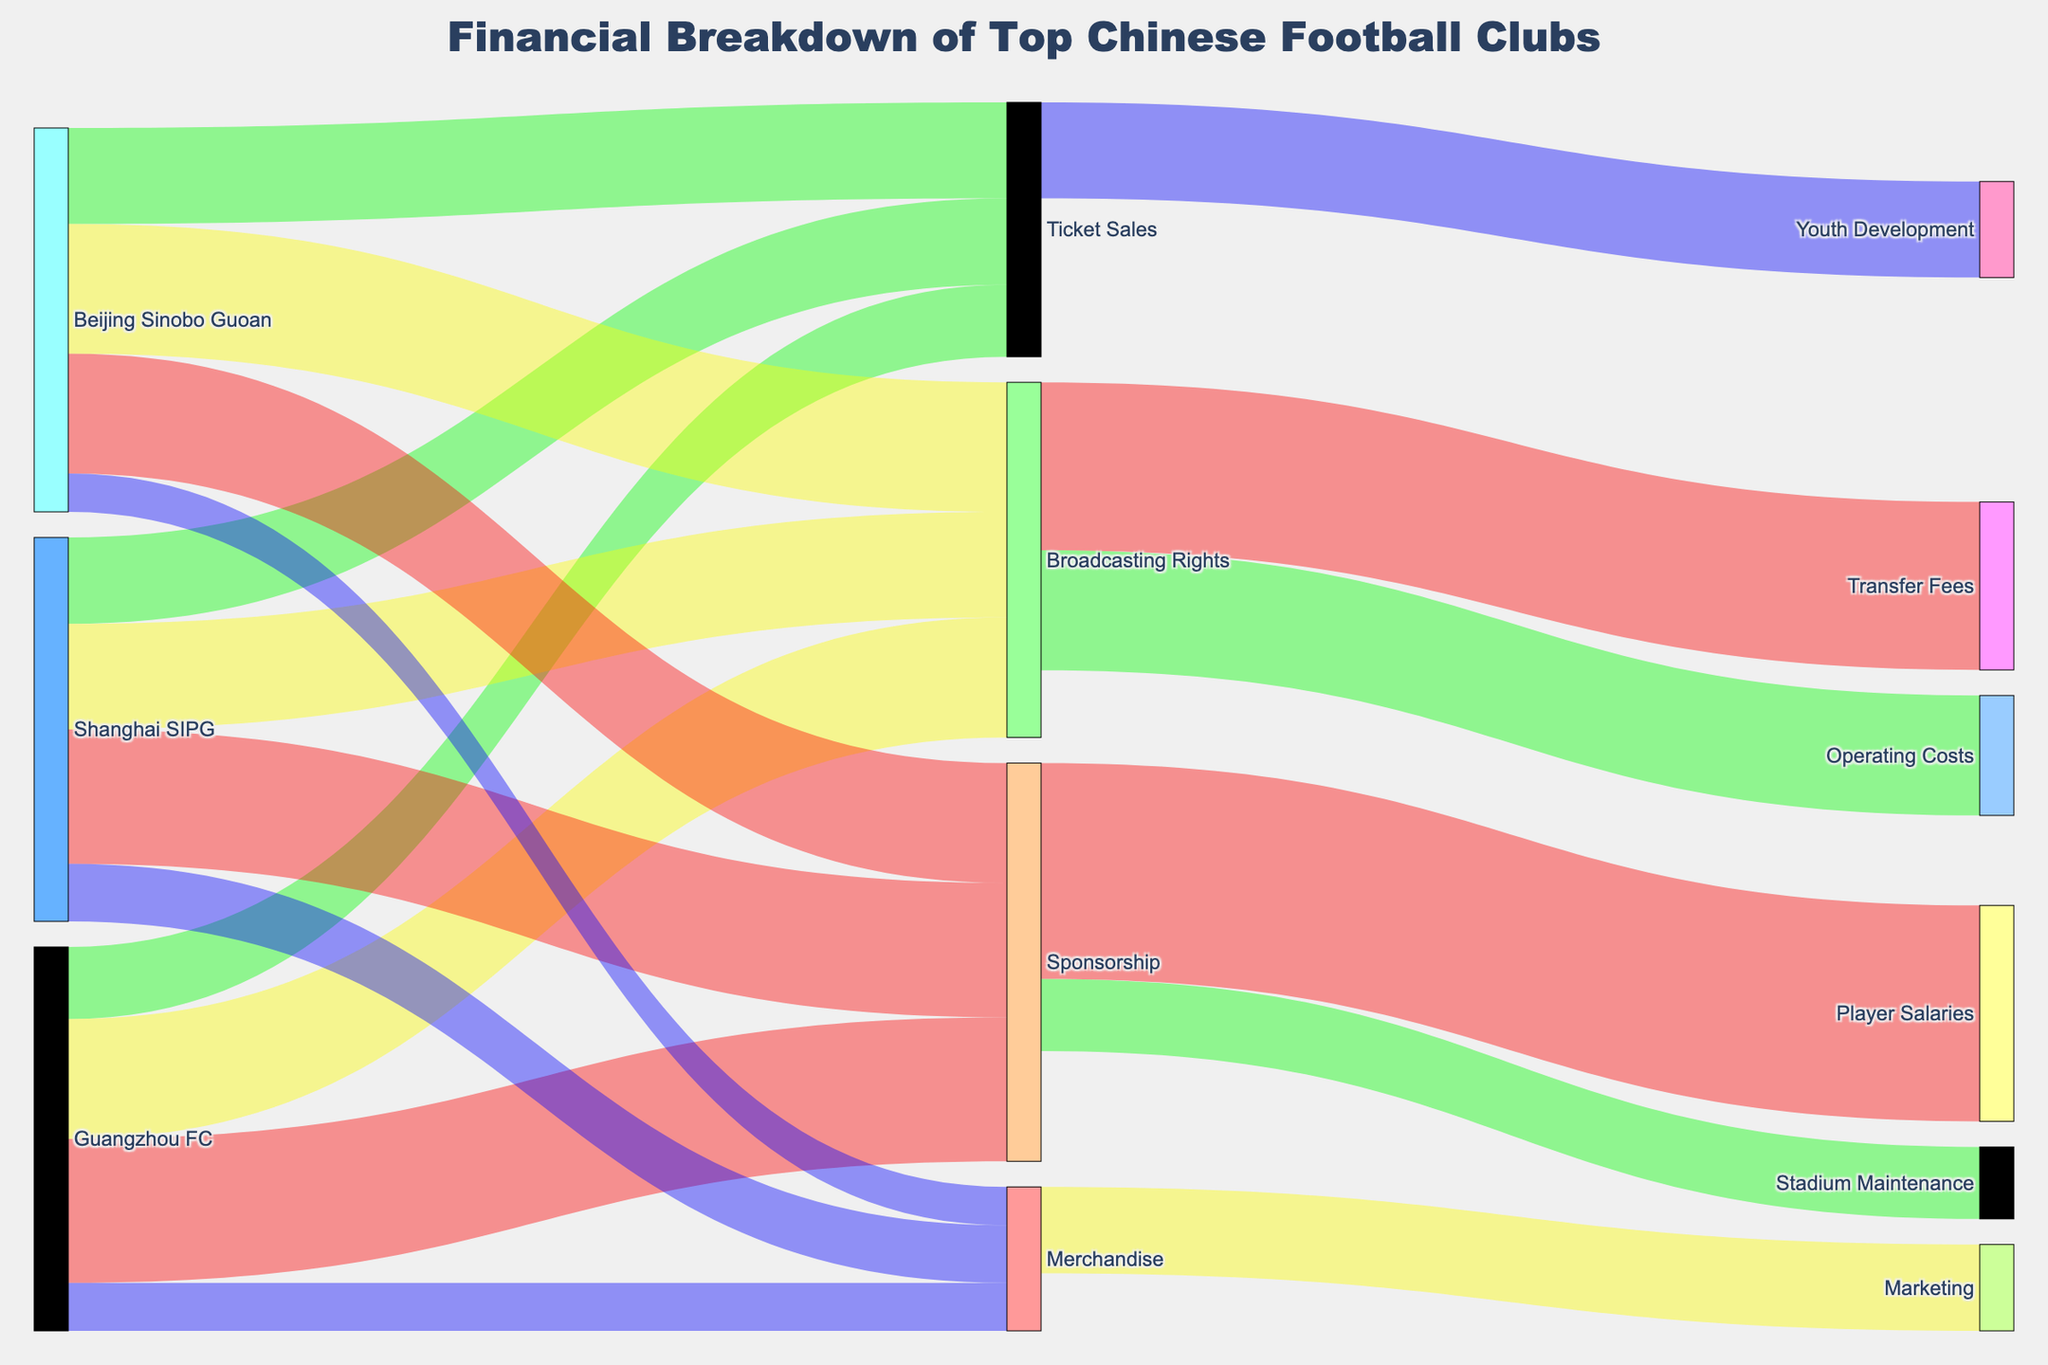What's the title of the figure? The title is usually displayed at the top of the figure, providing an overview of what the diagram represents. In this case, it is stated in the layout settings in the provided code.
Answer: Financial Breakdown of Top Chinese Football Clubs Which club generates the most revenue from broadcasting rights? To determine this, you need to compare the values associated with "Broadcasting Rights" for all clubs. The values are Guangzhou FC: 25, Shanghai SIPG: 22, Beijing Sinobo Guoan: 27.
Answer: Beijing Sinobo Guoan How much total revenue does Guangzhou FC generate across all sources? Sum the revenue values of Guangzhou FC from all four sources: Sponsorship (30) + Ticket Sales (15) + Merchandise (10) + Broadcasting Rights (25).
Answer: 80 What is the combined expenditure on Youth Development and Stadium Maintenance? Add the values for Youth Development and Stadium Maintenance from the expenditures: Youth Development (20) + Stadium Maintenance (15).
Answer: 35 Which category has the highest revenue stream across all clubs? Compare the total values for Sponsorship, Ticket Sales, Merchandise, and Broadcasting Rights by summing respective values across all clubs. Sponsorship (30+28+25), Ticket Sales (15+18+20), Merchandise (10+12+8), Broadcasting Rights (25+22+27).
Answer: Sponsorship Between Shanghai SIPG and Beijing Sinobo Guoan, which club earns more from ticket sales? Compare the ticket sales values for these two clubs: Shanghai SIPG (18) and Beijing Sinobo Guoan (20).
Answer: Beijing Sinobo Guoan What is the overall total expenditure covered by Broadcasting Rights? Sum the values from Broadcasting Rights to various expenditures: Transfer Fees (35) + Operating Costs (25).
Answer: 60 By how much does Beijing Sinobo Guoan's revenue from merchandise differ from Guangzhou FC's? Subtract the revenue value of Merchandise for Beijing Sinobo Guoan (8) from Guangzhou FC (10).
Answer: 2 Out of all clubs, which one has the lowest combined revenue, and what is its total? Sum the revenue values for each club and find the one with the lowest total. Compare Guangzhou FC (80), Shanghai SIPG (80), Beijing Sinobo Guoan (80). All clubs have the same total revenue.
Answer: All clubs have the same total revenue How does the total expenditure on Marketing compare to the total revenue from Merchandise? Compare the Marketing expenditure value (18) with the total revenue from Merchandise across all clubs: Guangzhou FC (10) + Shanghai SIPG (12) + Beijing Sinobo Guoan (8).
Answer: Equal 